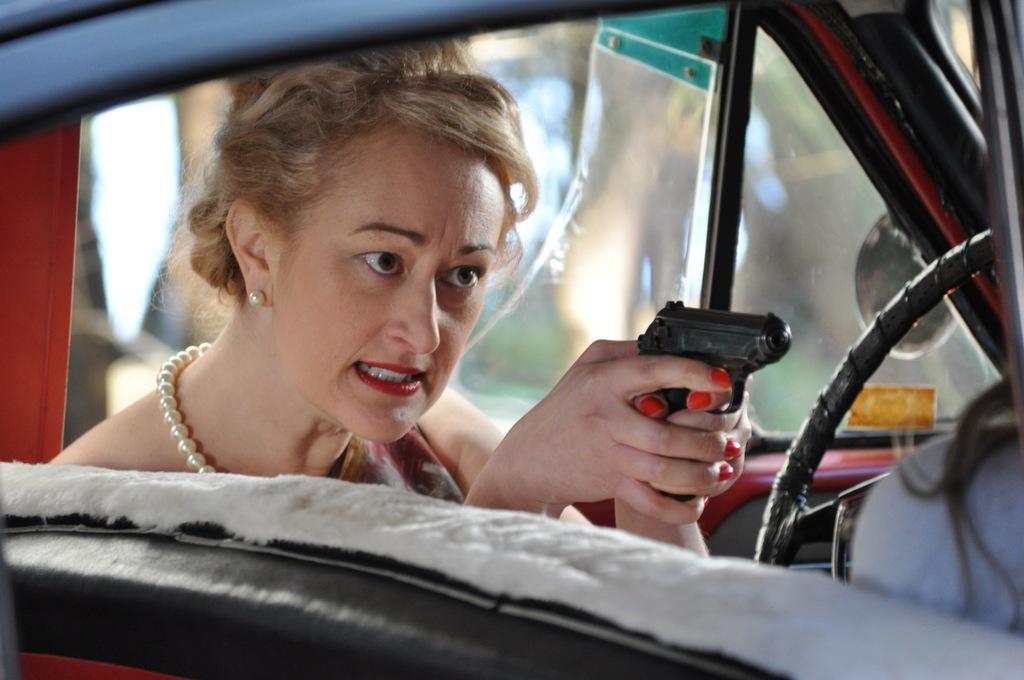Could you give a brief overview of what you see in this image? There is a lady in the foreground area of the image holding a pistol in her hand, it seems like she is sitting in a vehicle and background area is blur. 